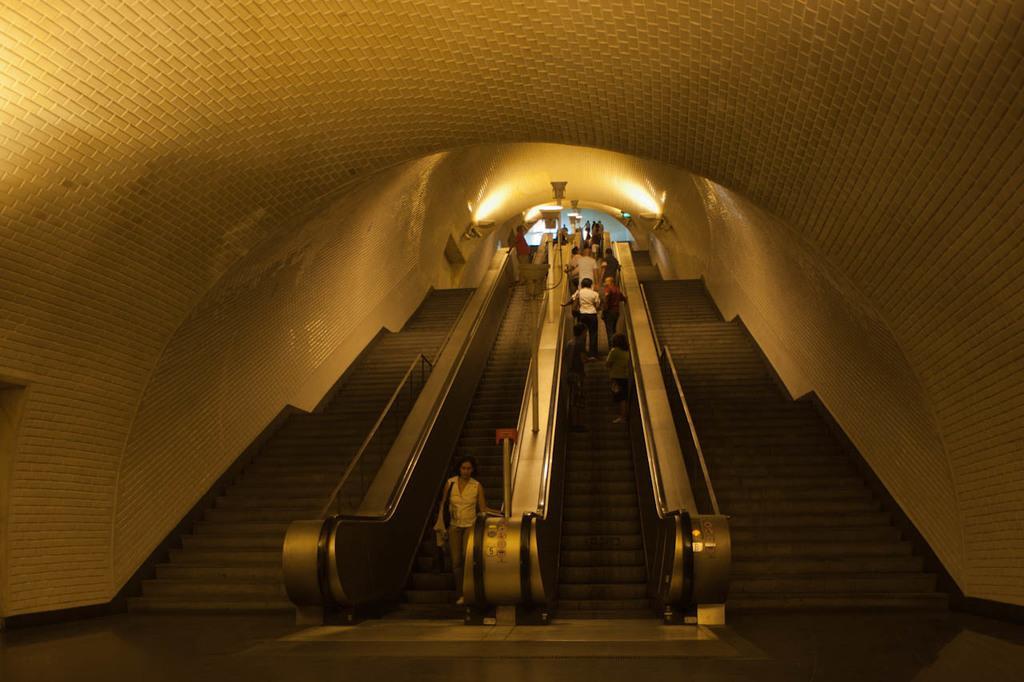Could you give a brief overview of what you see in this image? In this image I can see some people standing on the escalator under the curved roof. 